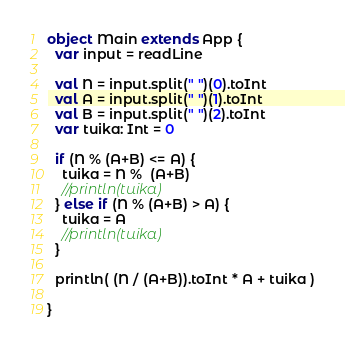Convert code to text. <code><loc_0><loc_0><loc_500><loc_500><_Scala_>object Main extends App {
  var input = readLine
  
  val N = input.split(" ")(0).toInt
  val A = input.split(" ")(1).toInt
  val B = input.split(" ")(2).toInt  
  var tuika: Int = 0
  
  if (N % (A+B) <= A) {
    tuika = N %  (A+B)
    //println(tuika)
  } else if (N % (A+B) > A) {
    tuika = A
    //println(tuika)
  }
  
  println( (N / (A+B)).toInt * A + tuika )

}</code> 